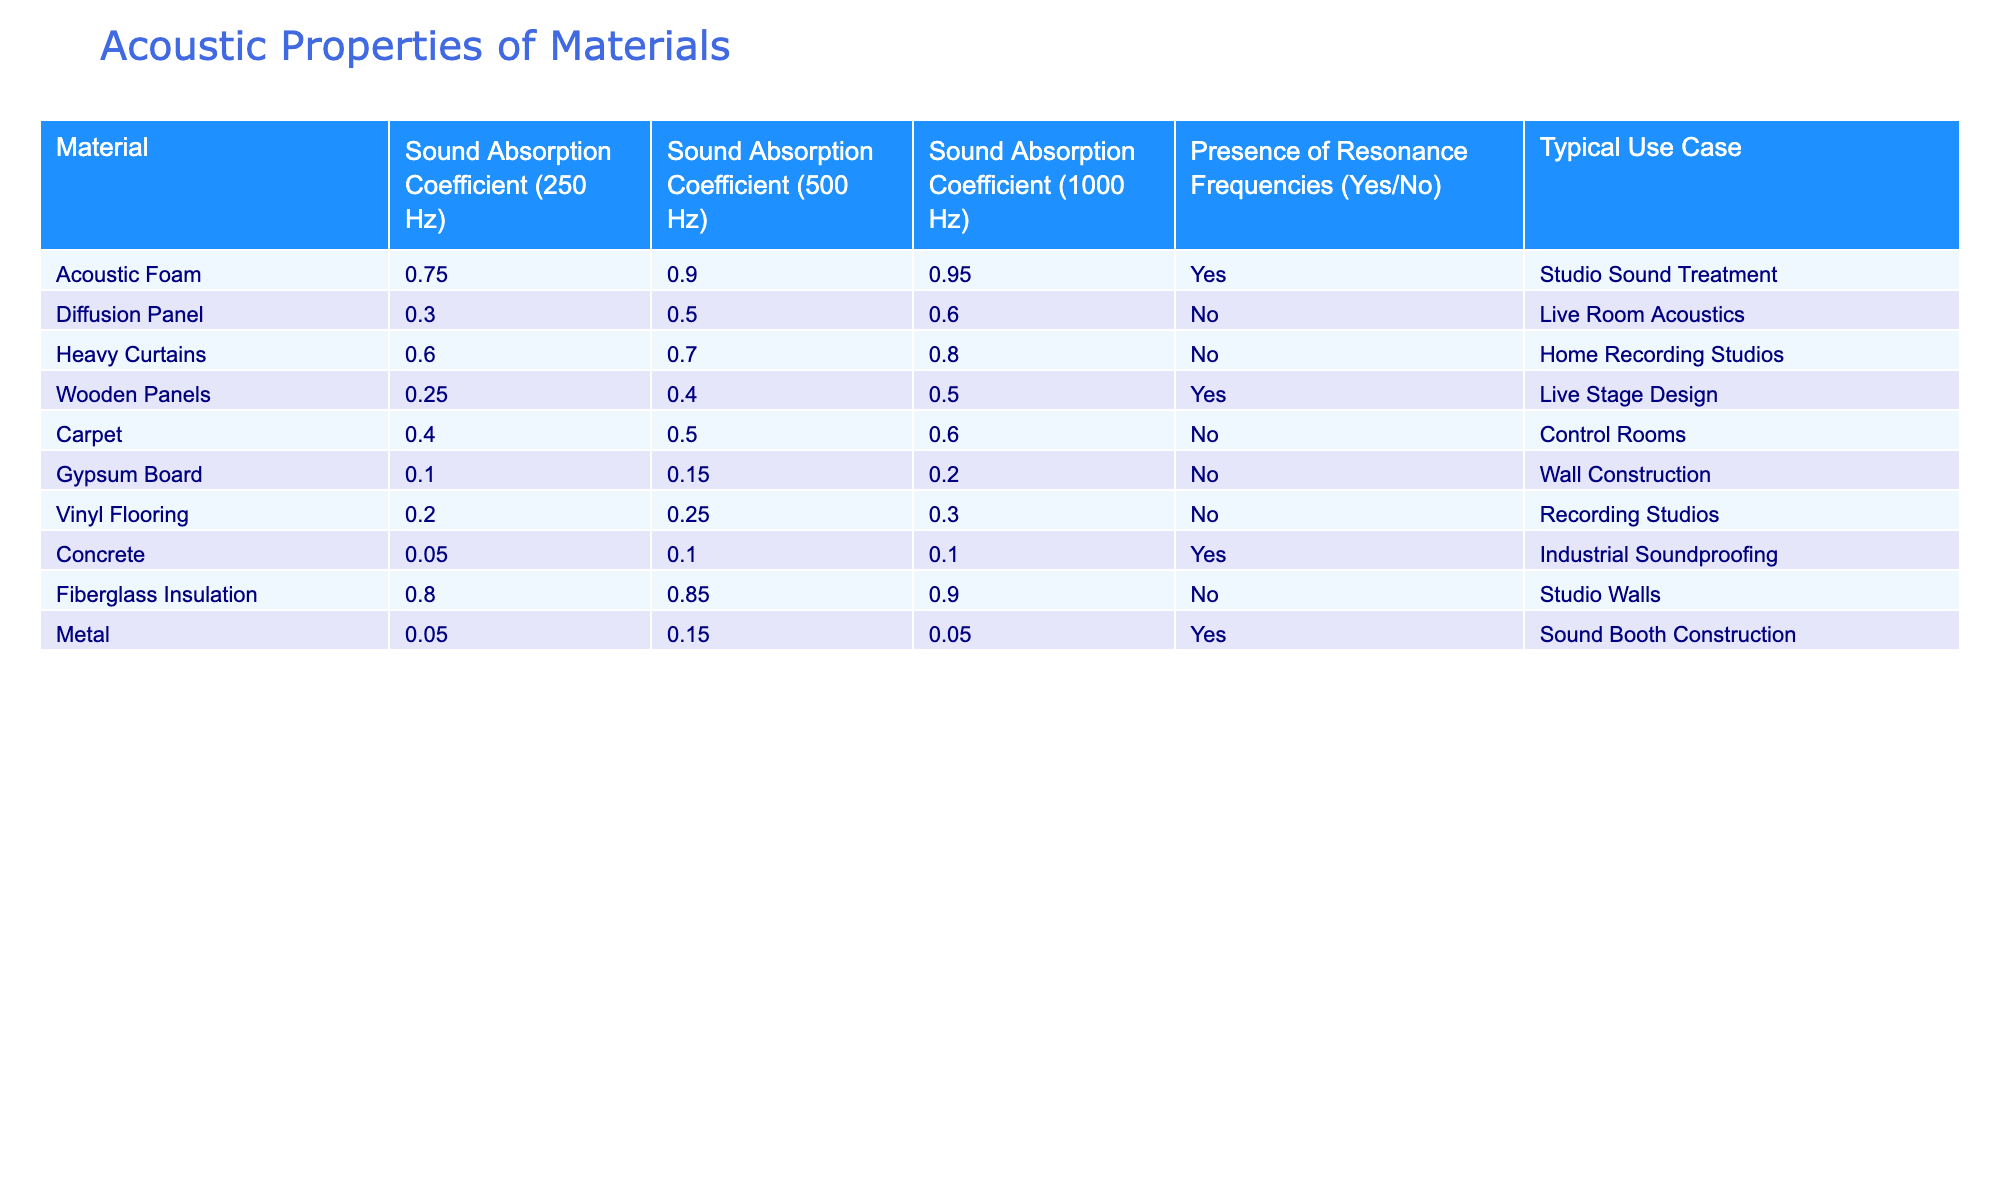What is the sound absorption coefficient of Acoustic Foam at 1000 Hz? According to the table, the sound absorption coefficient of Acoustic Foam is listed as 0.95 when measured at 1000 Hz.
Answer: 0.95 Which material has the highest sound absorption coefficient at 250 Hz? By reviewing the sound absorption coefficients at 250 Hz, Acoustic Foam has the highest value of 0.75 compared to other materials.
Answer: Acoustic Foam Do Heavy Curtains have resonance frequencies? The table states that Heavy Curtains do not have resonance frequencies, shown by the "No" in the relevant column.
Answer: No What is the average sound absorption coefficient at 500 Hz for materials with resonance frequencies? The materials with resonance frequencies are Acoustic Foam, Wooden Panels, Concrete, and Metal. Their sound absorption coefficients at 500 Hz are 0.90, 0.40, 0.10, and 0.15 respectively. Summing these gives 0.90 + 0.40 + 0.10 + 0.15 = 1.55. There are 4 materials, so the average is 1.55 / 4 = 0.3875.
Answer: 0.3875 Which material is typically used for studio sound treatment, and what is its sound absorption coefficient at 500 Hz? Acoustic Foam is used for studio sound treatment, and its sound absorption coefficient at 500 Hz is 0.90 according to the table.
Answer: Acoustic Foam, 0.90 What is the sound absorption coefficient for Concrete at 1000 Hz? The sound absorption coefficient for Concrete at 1000 Hz is listed as 0.10 in the table.
Answer: 0.10 How many materials have a sound absorption coefficient greater than 0.60 at 250 Hz? From the table, the materials with a sound absorption coefficient greater than 0.60 at 250 Hz are Acoustic Foam (0.75) and Heavy Curtains (0.60). Therefore, there are a total of 2 materials that meet this criterion.
Answer: 2 Is Vinyl Flooring commonly used for industrial soundproofing? Referring to the typical use case column, Vinyl Flooring's use is for recording studios, while industrial soundproofing is associated with Concrete. Therefore, Vinyl Flooring is not used for industrial soundproofing.
Answer: No What is the difference in sound absorption coefficients at 500 Hz between Fiberglass Insulation and Vinyl Flooring? The sound absorption coefficient for Fiberglass Insulation at 500 Hz is 0.85, while for Vinyl Flooring it is 0.25. Thus, the difference is 0.85 - 0.25 = 0.60.
Answer: 0.60 